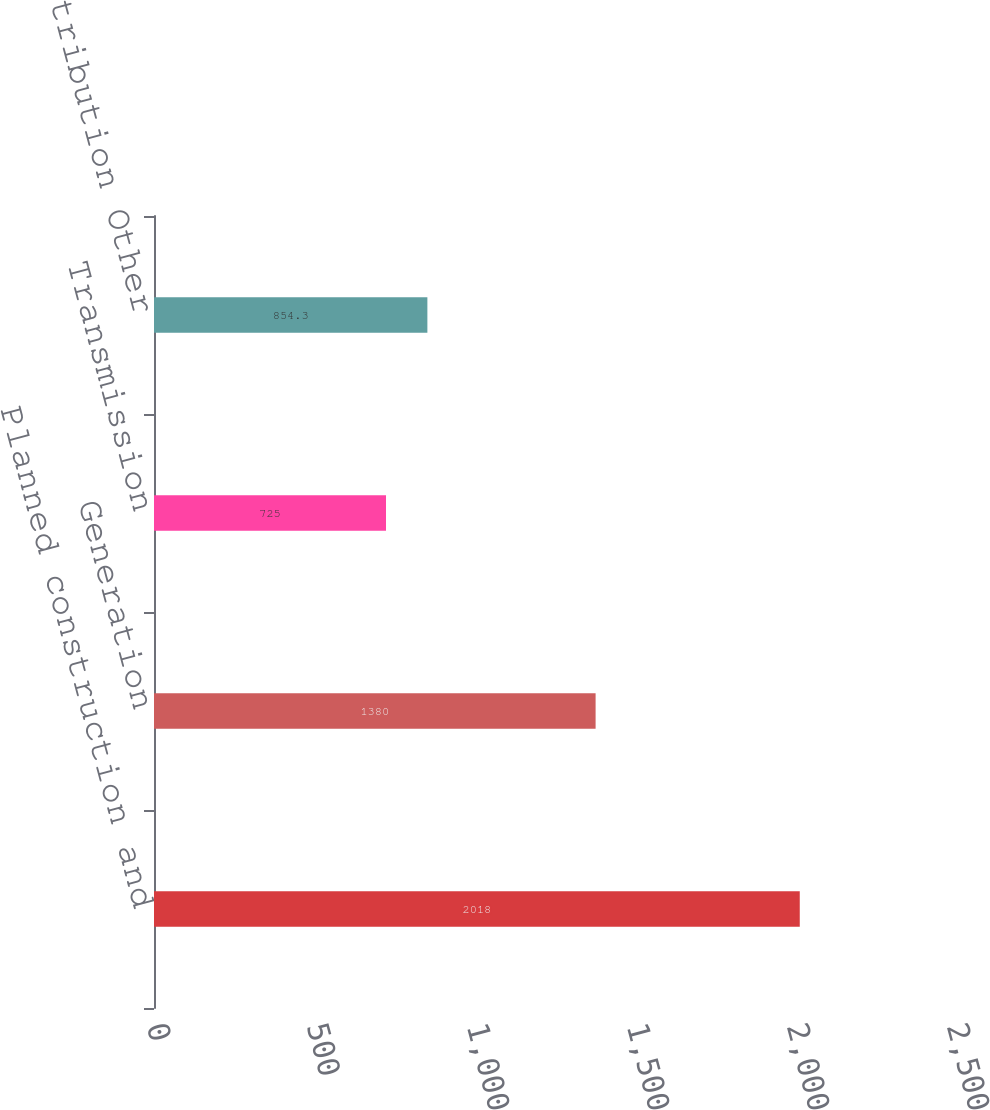Convert chart. <chart><loc_0><loc_0><loc_500><loc_500><bar_chart><fcel>Planned construction and<fcel>Generation<fcel>Transmission<fcel>Distribution Other<nl><fcel>2018<fcel>1380<fcel>725<fcel>854.3<nl></chart> 